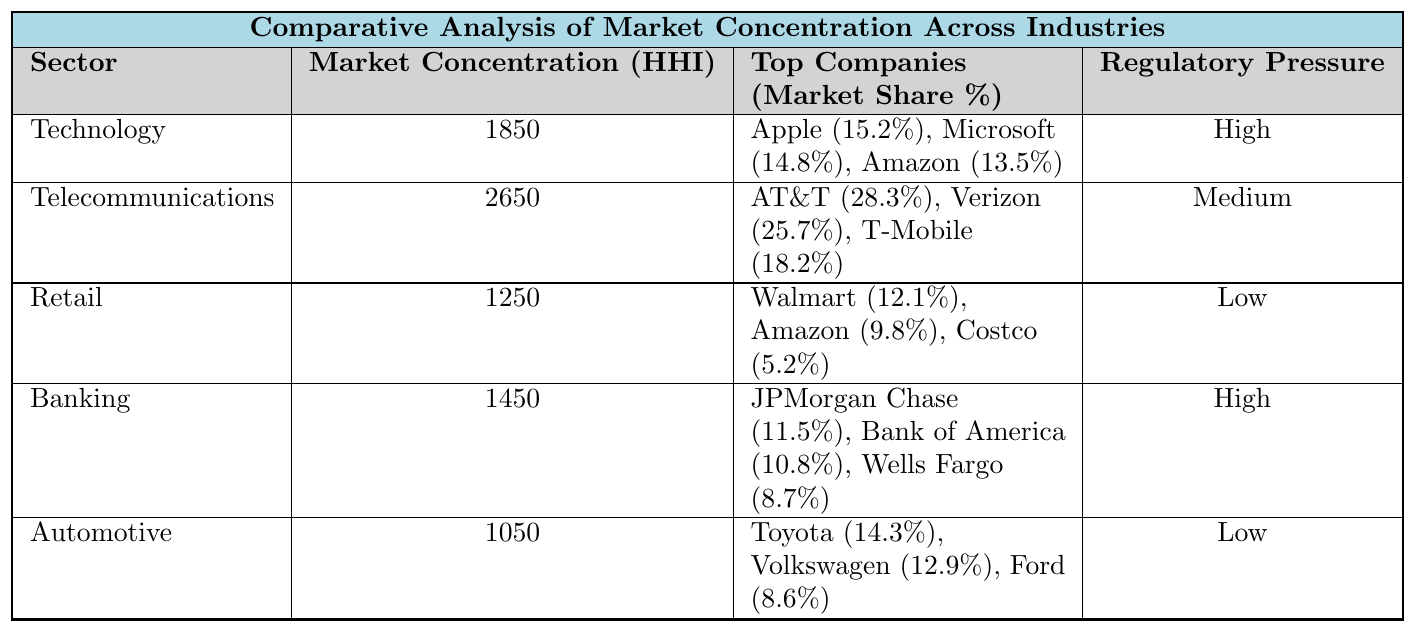What is the Market Concentration (HHI) for the Technology sector? According to the table, the Market Concentration (HHI) for the Technology sector is listed directly as 1850.
Answer: 1850 Which sector has the highest Market Concentration (HHI)? By comparing the HHI values in the table, Telecommunications at 2650 has the highest Market Concentration (HHI) among all sectors.
Answer: Telecommunications What is the total Market Share (%) of the top three companies in the Telecommunications sector? The Market Share values for the top companies in Telecommunications are AT&T (28.3%), Verizon (25.7%), and T-Mobile (18.2%). Adding these up gives (28.3 + 25.7 + 18.2) = 72.2%.
Answer: 72.2% Which sector has low regulatory pressure? By reviewing the "Regulatory Pressure" column in the table, both Retail and Automotive sectors are marked as having Low regulatory pressure.
Answer: Retail and Automotive Is the HHI for the Banking sector higher than that for the Retail sector? The HHI for Banking is 1450 and for Retail is 1250. Since 1450 is greater than 1250, it confirms that Banking has a higher HHI than Retail.
Answer: Yes What is the average Market Concentration (HHI) of the sectors labeled as High in regulatory pressure? The sectors with High regulatory pressure are Technology (1850) and Banking (1450). The average is calculated as (1850 + 1450) / 2 = 1650.
Answer: 1650 If we consider all provided sectors, which one has the lowest Market Share (%) for its top company? Looking at the top companies' Market Share in each sector, Automotive's top company, Toyota, has 14.3%, which is the lowest among the highest shares listed across all sectors.
Answer: Automotive (Toyota = 14.3%) What is the total Market Concentration (HHI) of all sectors? To find the total HHI, we sum up the HHI values for all sectors: (1850 + 2650 + 1250 + 1450 + 1050) = 6300.
Answer: 6300 How many sectors have a Market Concentration (HHI) above 1500? Examining the HHI values, only Telecommunications (2650) and Technology (1850) exceed 1500. Therefore, there are 2 sectors with HHI above 1500.
Answer: 2 What relationship exists between Market Concentration (HHI) and Regulatory Pressure in the given sectors? Upon reviewing the table, we see that higher concentration (e.g., Telecommunications and Technology) correlates with High regulatory pressure, while lower concentration (e.g., Retail and Automotive) aligns with Low regulatory pressure. This suggests a trend where higher market concentration invites greater regulatory scrutiny.
Answer: Higher concentration correlates with higher regulatory pressure 